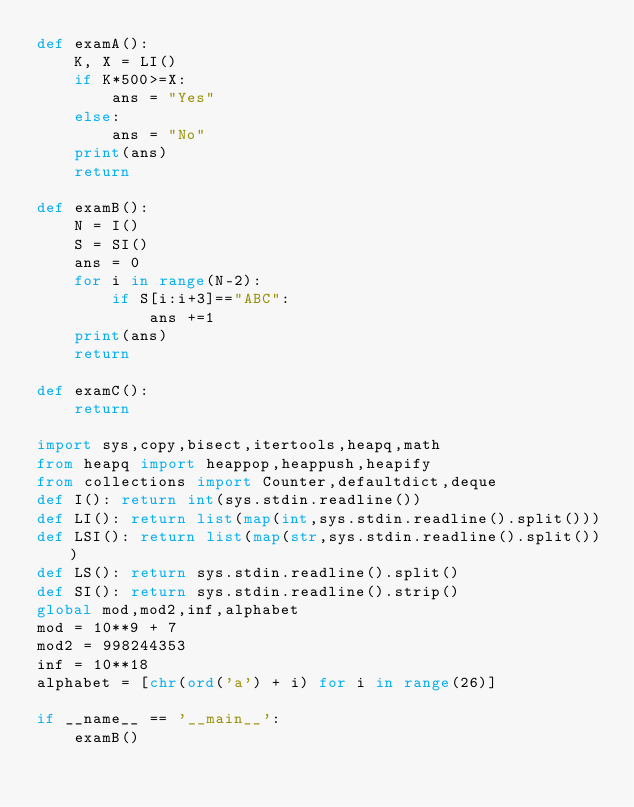<code> <loc_0><loc_0><loc_500><loc_500><_Python_>def examA():
    K, X = LI()
    if K*500>=X:
        ans = "Yes"
    else:
        ans = "No"
    print(ans)
    return

def examB():
    N = I()
    S = SI()
    ans = 0
    for i in range(N-2):
        if S[i:i+3]=="ABC":
            ans +=1
    print(ans)
    return

def examC():
    return

import sys,copy,bisect,itertools,heapq,math
from heapq import heappop,heappush,heapify
from collections import Counter,defaultdict,deque
def I(): return int(sys.stdin.readline())
def LI(): return list(map(int,sys.stdin.readline().split()))
def LSI(): return list(map(str,sys.stdin.readline().split()))
def LS(): return sys.stdin.readline().split()
def SI(): return sys.stdin.readline().strip()
global mod,mod2,inf,alphabet
mod = 10**9 + 7
mod2 = 998244353
inf = 10**18
alphabet = [chr(ord('a') + i) for i in range(26)]

if __name__ == '__main__':
    examB()
</code> 